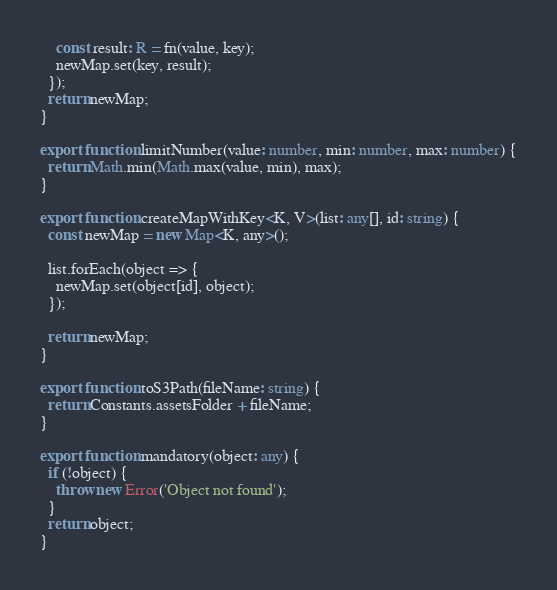Convert code to text. <code><loc_0><loc_0><loc_500><loc_500><_TypeScript_>    const result: R = fn(value, key);
    newMap.set(key, result);
  });
  return newMap;
}

export function limitNumber(value: number, min: number, max: number) {
  return Math.min(Math.max(value, min), max);
}

export function createMapWithKey<K, V>(list: any[], id: string) {
  const newMap = new Map<K, any>();

  list.forEach(object => {
    newMap.set(object[id], object);
  });

  return newMap;
}

export function toS3Path(fileName: string) {
  return Constants.assetsFolder + fileName;
}

export function mandatory(object: any) {
  if (!object) {
    throw new Error('Object not found');
  }
  return object;
}
</code> 